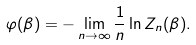Convert formula to latex. <formula><loc_0><loc_0><loc_500><loc_500>\varphi ( \beta ) = - \lim _ { n \rightarrow \infty } \frac { 1 } { n } \ln Z _ { n } ( \beta ) .</formula> 